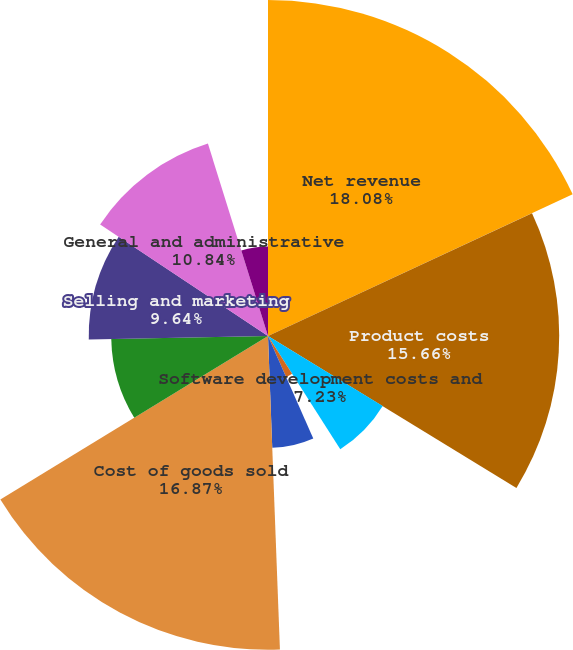<chart> <loc_0><loc_0><loc_500><loc_500><pie_chart><fcel>Net revenue<fcel>Product costs<fcel>Software development costs and<fcel>Internal royalties<fcel>Licenses<fcel>Cost of goods sold<fcel>Gross profit<fcel>Selling and marketing<fcel>General and administrative<fcel>Research and development<nl><fcel>18.07%<fcel>15.66%<fcel>7.23%<fcel>2.41%<fcel>6.02%<fcel>16.87%<fcel>8.43%<fcel>9.64%<fcel>10.84%<fcel>4.82%<nl></chart> 